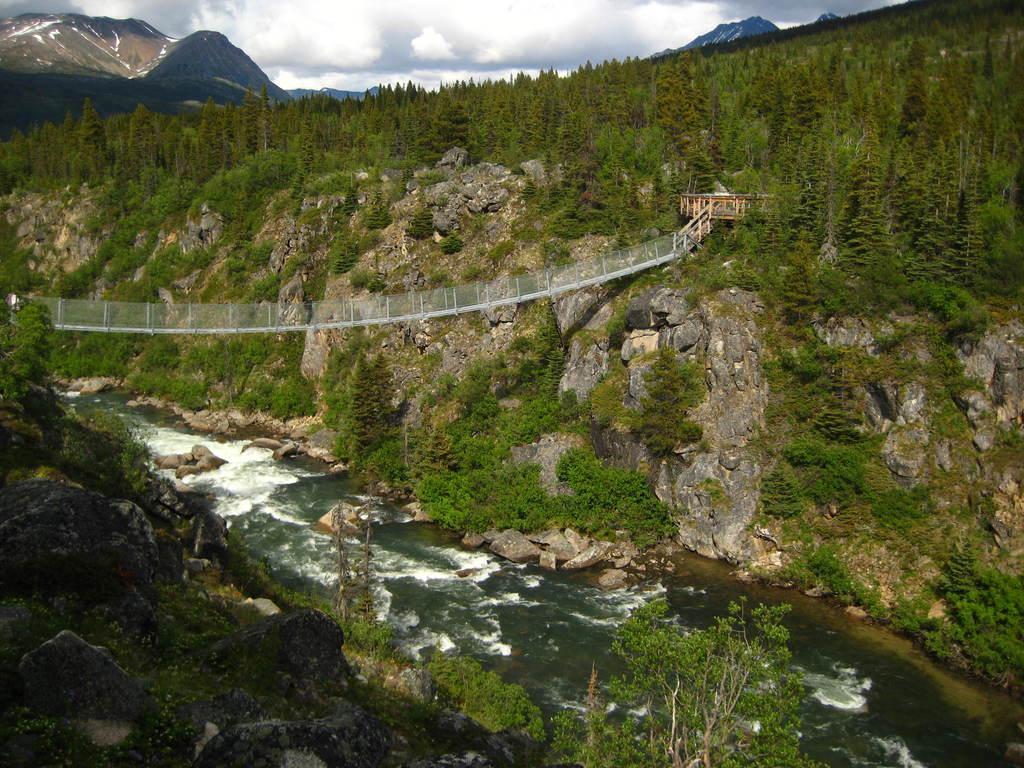Can you describe this image briefly? In the center of the image there is a bridge. At the bottom we can see a river and there are rocks. In the background there are hills, trees and sky. 